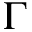<formula> <loc_0><loc_0><loc_500><loc_500>\Gamma</formula> 